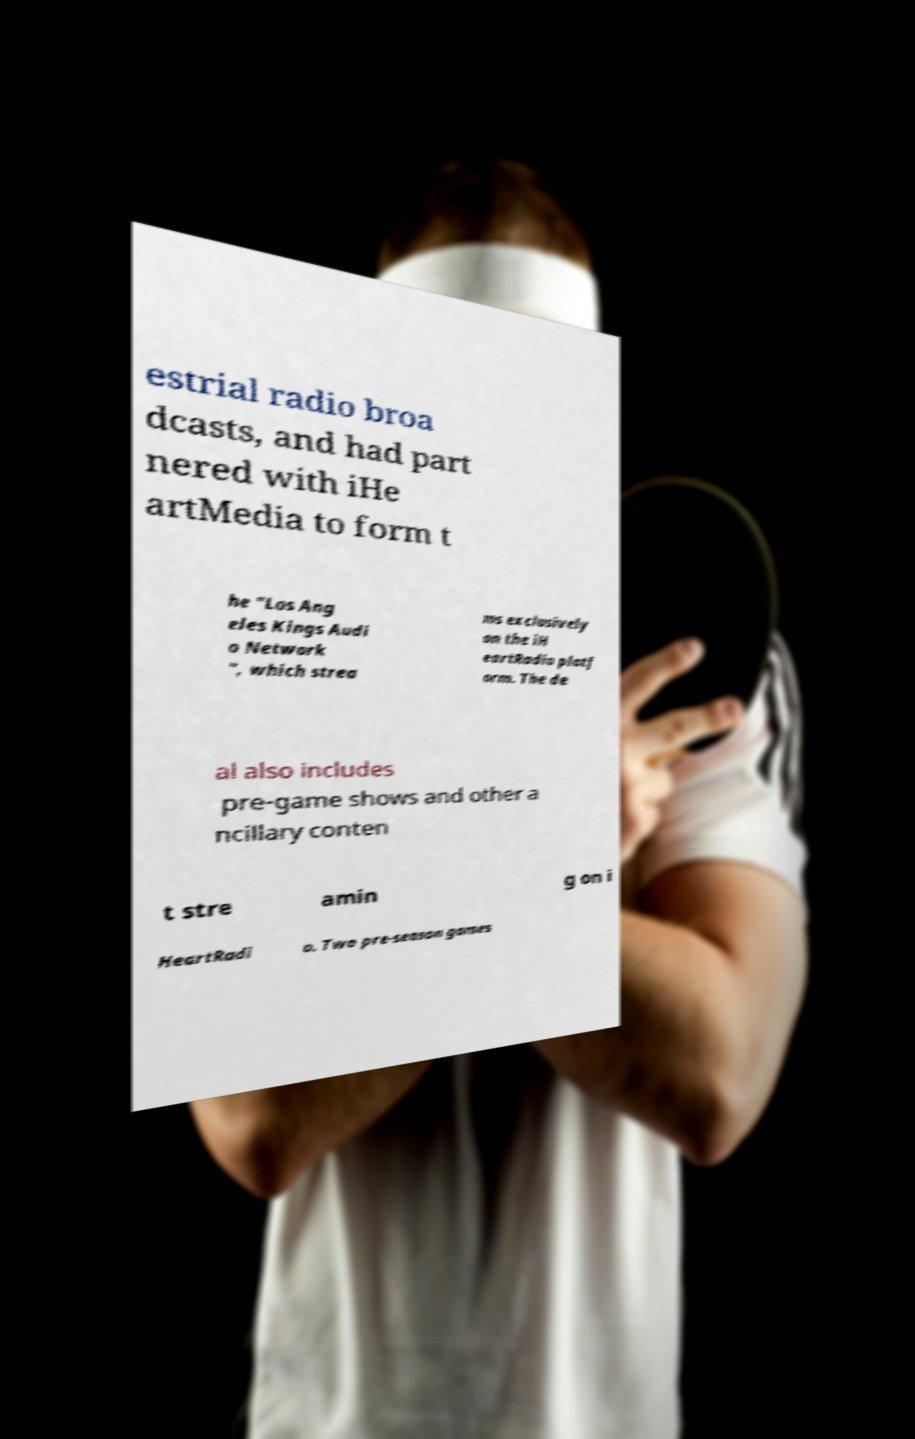What messages or text are displayed in this image? I need them in a readable, typed format. estrial radio broa dcasts, and had part nered with iHe artMedia to form t he "Los Ang eles Kings Audi o Network ", which strea ms exclusively on the iH eartRadio platf orm. The de al also includes pre-game shows and other a ncillary conten t stre amin g on i HeartRadi o. Two pre-season games 